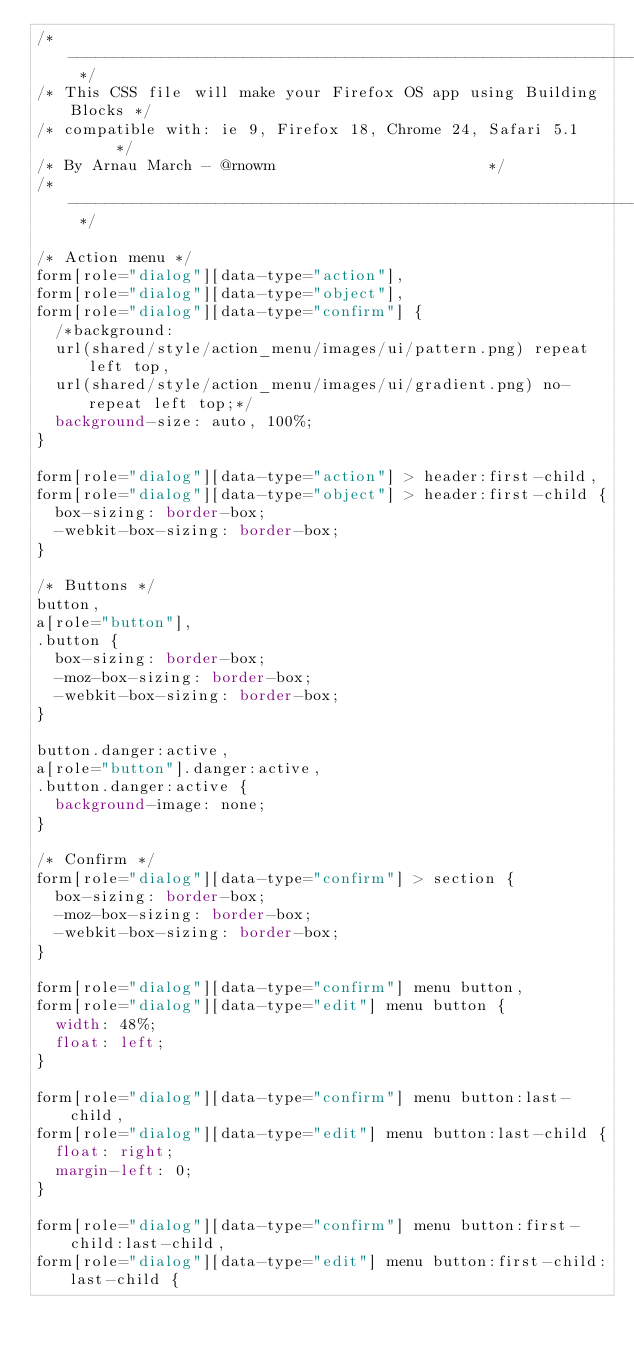Convert code to text. <code><loc_0><loc_0><loc_500><loc_500><_CSS_>/* ----------------------------------------------------------------- */
/* This CSS file will make your Firefox OS app using Building Blocks */
/* compatible with: ie 9, Firefox 18, Chrome 24, Safari 5.1      */
/* By Arnau March - @rnowm                       */
/* ----------------------------------------------------------------- */

/* Action menu */
form[role="dialog"][data-type="action"],
form[role="dialog"][data-type="object"],
form[role="dialog"][data-type="confirm"] {
  /*background:
  url(shared/style/action_menu/images/ui/pattern.png) repeat left top,
  url(shared/style/action_menu/images/ui/gradient.png) no-repeat left top;*/
  background-size: auto, 100%;
}

form[role="dialog"][data-type="action"] > header:first-child,
form[role="dialog"][data-type="object"] > header:first-child {
  box-sizing: border-box;
  -webkit-box-sizing: border-box;
}

/* Buttons */
button,
a[role="button"],
.button {
  box-sizing: border-box;
  -moz-box-sizing: border-box;
  -webkit-box-sizing: border-box;
}

button.danger:active,
a[role="button"].danger:active,
.button.danger:active {
  background-image: none;
}

/* Confirm */
form[role="dialog"][data-type="confirm"] > section {
  box-sizing: border-box;
  -moz-box-sizing: border-box;
  -webkit-box-sizing: border-box;
}

form[role="dialog"][data-type="confirm"] menu button,
form[role="dialog"][data-type="edit"] menu button {
  width: 48%;
  float: left;
}

form[role="dialog"][data-type="confirm"] menu button:last-child,
form[role="dialog"][data-type="edit"] menu button:last-child {
  float: right;
  margin-left: 0;
}

form[role="dialog"][data-type="confirm"] menu button:first-child:last-child,
form[role="dialog"][data-type="edit"] menu button:first-child:last-child {</code> 